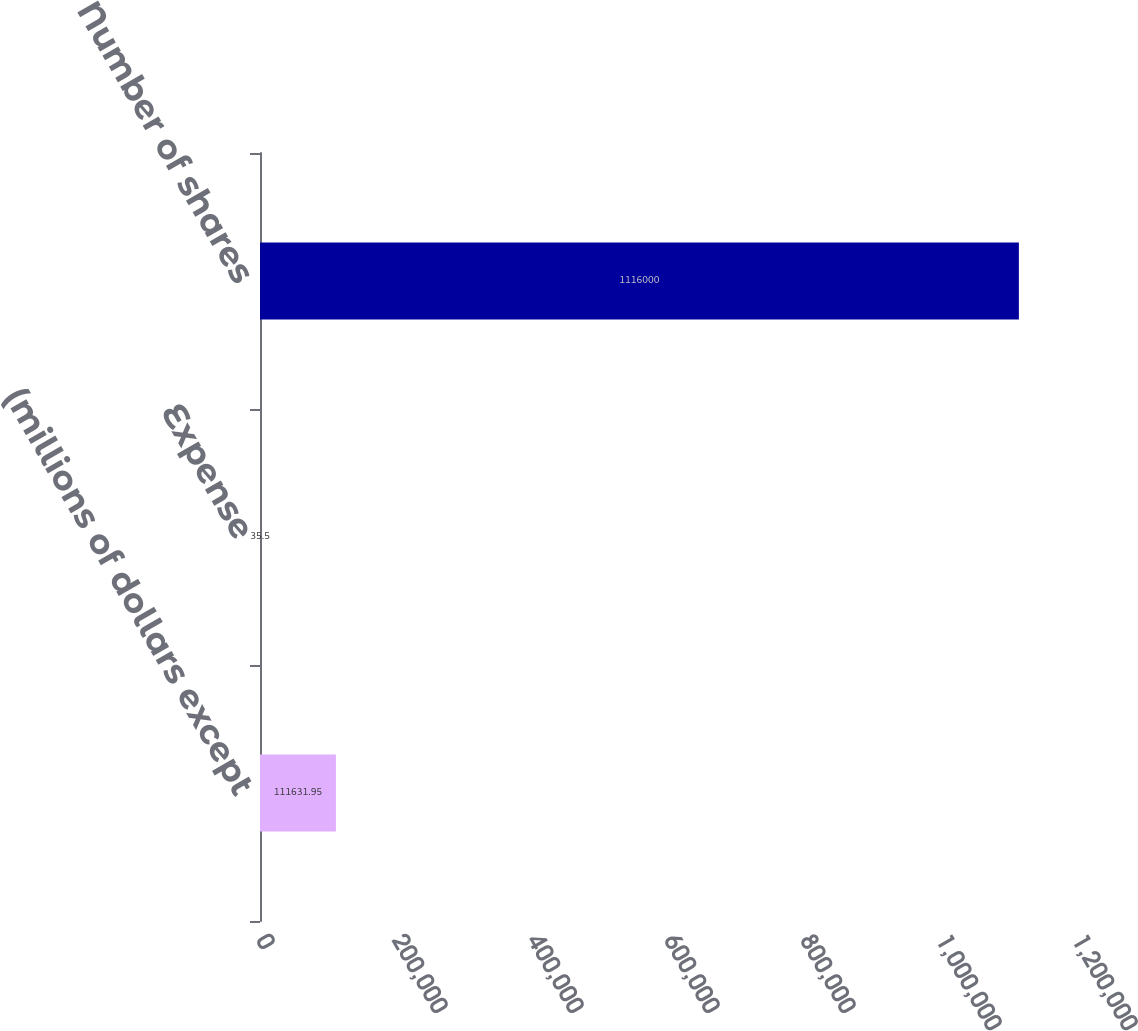Convert chart to OTSL. <chart><loc_0><loc_0><loc_500><loc_500><bar_chart><fcel>(millions of dollars except<fcel>Expense<fcel>Number of shares<nl><fcel>111632<fcel>35.5<fcel>1.116e+06<nl></chart> 